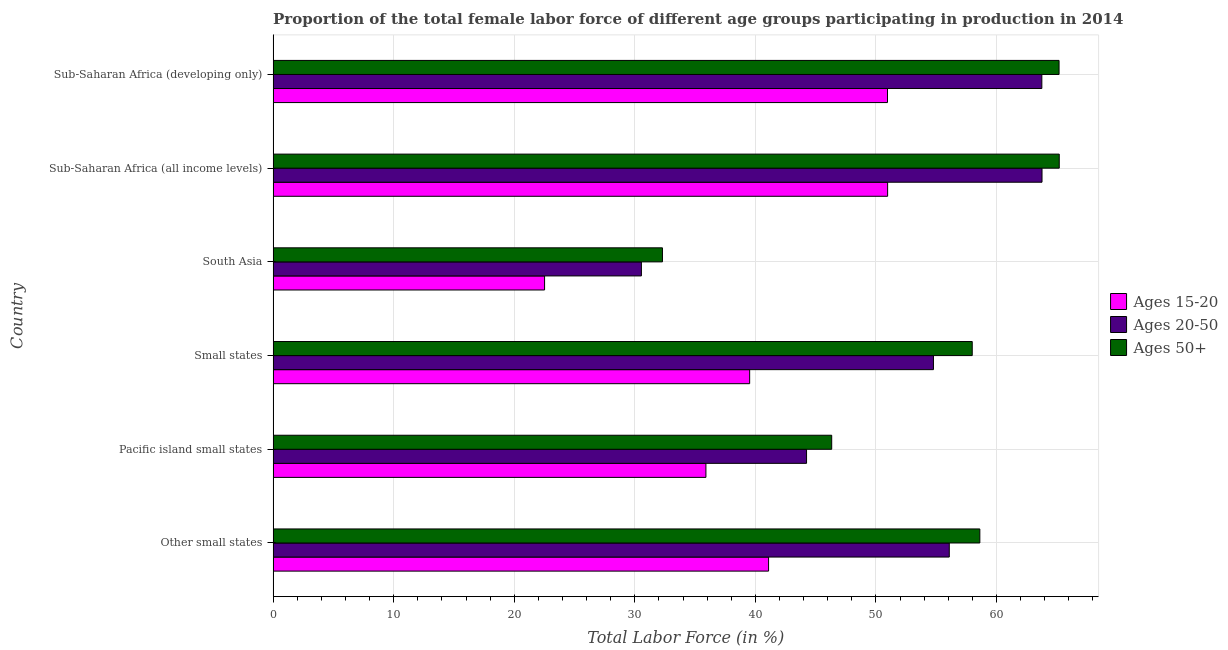How many different coloured bars are there?
Offer a very short reply. 3. How many groups of bars are there?
Your answer should be very brief. 6. Are the number of bars on each tick of the Y-axis equal?
Offer a terse response. Yes. How many bars are there on the 5th tick from the top?
Your answer should be compact. 3. What is the label of the 5th group of bars from the top?
Your answer should be compact. Pacific island small states. What is the percentage of female labor force within the age group 20-50 in Small states?
Make the answer very short. 54.77. Across all countries, what is the maximum percentage of female labor force within the age group 20-50?
Your answer should be very brief. 63.78. Across all countries, what is the minimum percentage of female labor force above age 50?
Ensure brevity in your answer.  32.29. In which country was the percentage of female labor force within the age group 20-50 maximum?
Your answer should be compact. Sub-Saharan Africa (all income levels). What is the total percentage of female labor force within the age group 20-50 in the graph?
Provide a succinct answer. 313.18. What is the difference between the percentage of female labor force above age 50 in South Asia and that in Sub-Saharan Africa (all income levels)?
Your response must be concise. -32.91. What is the difference between the percentage of female labor force within the age group 15-20 in South Asia and the percentage of female labor force within the age group 20-50 in Other small states?
Provide a short and direct response. -33.57. What is the average percentage of female labor force above age 50 per country?
Offer a very short reply. 54.27. What is the difference between the percentage of female labor force above age 50 and percentage of female labor force within the age group 20-50 in South Asia?
Keep it short and to the point. 1.75. What is the ratio of the percentage of female labor force within the age group 15-20 in Other small states to that in South Asia?
Your response must be concise. 1.82. Is the percentage of female labor force within the age group 20-50 in Other small states less than that in South Asia?
Keep it short and to the point. No. What is the difference between the highest and the second highest percentage of female labor force within the age group 15-20?
Offer a terse response. 0.01. What is the difference between the highest and the lowest percentage of female labor force above age 50?
Give a very brief answer. 32.91. In how many countries, is the percentage of female labor force within the age group 20-50 greater than the average percentage of female labor force within the age group 20-50 taken over all countries?
Your answer should be compact. 4. What does the 3rd bar from the top in Pacific island small states represents?
Offer a very short reply. Ages 15-20. What does the 3rd bar from the bottom in Pacific island small states represents?
Your answer should be compact. Ages 50+. Is it the case that in every country, the sum of the percentage of female labor force within the age group 15-20 and percentage of female labor force within the age group 20-50 is greater than the percentage of female labor force above age 50?
Your answer should be compact. Yes. Are all the bars in the graph horizontal?
Offer a terse response. Yes. How many countries are there in the graph?
Provide a short and direct response. 6. What is the difference between two consecutive major ticks on the X-axis?
Offer a very short reply. 10. How are the legend labels stacked?
Your response must be concise. Vertical. What is the title of the graph?
Give a very brief answer. Proportion of the total female labor force of different age groups participating in production in 2014. Does "Food" appear as one of the legend labels in the graph?
Provide a short and direct response. No. What is the label or title of the Y-axis?
Give a very brief answer. Country. What is the Total Labor Force (in %) of Ages 15-20 in Other small states?
Offer a very short reply. 41.1. What is the Total Labor Force (in %) in Ages 20-50 in Other small states?
Your response must be concise. 56.08. What is the Total Labor Force (in %) in Ages 50+ in Other small states?
Give a very brief answer. 58.62. What is the Total Labor Force (in %) of Ages 15-20 in Pacific island small states?
Your answer should be very brief. 35.9. What is the Total Labor Force (in %) of Ages 20-50 in Pacific island small states?
Your answer should be very brief. 44.25. What is the Total Labor Force (in %) of Ages 50+ in Pacific island small states?
Provide a short and direct response. 46.33. What is the Total Labor Force (in %) of Ages 15-20 in Small states?
Offer a terse response. 39.53. What is the Total Labor Force (in %) of Ages 20-50 in Small states?
Give a very brief answer. 54.77. What is the Total Labor Force (in %) of Ages 50+ in Small states?
Provide a succinct answer. 57.99. What is the Total Labor Force (in %) of Ages 15-20 in South Asia?
Give a very brief answer. 22.52. What is the Total Labor Force (in %) in Ages 20-50 in South Asia?
Keep it short and to the point. 30.55. What is the Total Labor Force (in %) of Ages 50+ in South Asia?
Offer a terse response. 32.29. What is the Total Labor Force (in %) in Ages 15-20 in Sub-Saharan Africa (all income levels)?
Offer a very short reply. 50.97. What is the Total Labor Force (in %) in Ages 20-50 in Sub-Saharan Africa (all income levels)?
Offer a terse response. 63.78. What is the Total Labor Force (in %) in Ages 50+ in Sub-Saharan Africa (all income levels)?
Offer a terse response. 65.2. What is the Total Labor Force (in %) of Ages 15-20 in Sub-Saharan Africa (developing only)?
Keep it short and to the point. 50.96. What is the Total Labor Force (in %) in Ages 20-50 in Sub-Saharan Africa (developing only)?
Make the answer very short. 63.76. What is the Total Labor Force (in %) of Ages 50+ in Sub-Saharan Africa (developing only)?
Your answer should be compact. 65.19. Across all countries, what is the maximum Total Labor Force (in %) in Ages 15-20?
Provide a succinct answer. 50.97. Across all countries, what is the maximum Total Labor Force (in %) in Ages 20-50?
Give a very brief answer. 63.78. Across all countries, what is the maximum Total Labor Force (in %) in Ages 50+?
Give a very brief answer. 65.2. Across all countries, what is the minimum Total Labor Force (in %) in Ages 15-20?
Give a very brief answer. 22.52. Across all countries, what is the minimum Total Labor Force (in %) of Ages 20-50?
Your response must be concise. 30.55. Across all countries, what is the minimum Total Labor Force (in %) of Ages 50+?
Offer a terse response. 32.29. What is the total Total Labor Force (in %) of Ages 15-20 in the graph?
Make the answer very short. 240.96. What is the total Total Labor Force (in %) in Ages 20-50 in the graph?
Your answer should be very brief. 313.18. What is the total Total Labor Force (in %) of Ages 50+ in the graph?
Give a very brief answer. 325.62. What is the difference between the Total Labor Force (in %) of Ages 15-20 in Other small states and that in Pacific island small states?
Give a very brief answer. 5.2. What is the difference between the Total Labor Force (in %) in Ages 20-50 in Other small states and that in Pacific island small states?
Offer a terse response. 11.84. What is the difference between the Total Labor Force (in %) of Ages 50+ in Other small states and that in Pacific island small states?
Offer a terse response. 12.29. What is the difference between the Total Labor Force (in %) in Ages 15-20 in Other small states and that in Small states?
Keep it short and to the point. 1.57. What is the difference between the Total Labor Force (in %) in Ages 20-50 in Other small states and that in Small states?
Your answer should be very brief. 1.31. What is the difference between the Total Labor Force (in %) in Ages 50+ in Other small states and that in Small states?
Offer a terse response. 0.63. What is the difference between the Total Labor Force (in %) of Ages 15-20 in Other small states and that in South Asia?
Ensure brevity in your answer.  18.58. What is the difference between the Total Labor Force (in %) of Ages 20-50 in Other small states and that in South Asia?
Make the answer very short. 25.54. What is the difference between the Total Labor Force (in %) in Ages 50+ in Other small states and that in South Asia?
Your response must be concise. 26.32. What is the difference between the Total Labor Force (in %) in Ages 15-20 in Other small states and that in Sub-Saharan Africa (all income levels)?
Make the answer very short. -9.87. What is the difference between the Total Labor Force (in %) in Ages 20-50 in Other small states and that in Sub-Saharan Africa (all income levels)?
Make the answer very short. -7.69. What is the difference between the Total Labor Force (in %) in Ages 50+ in Other small states and that in Sub-Saharan Africa (all income levels)?
Provide a short and direct response. -6.59. What is the difference between the Total Labor Force (in %) of Ages 15-20 in Other small states and that in Sub-Saharan Africa (developing only)?
Ensure brevity in your answer.  -9.86. What is the difference between the Total Labor Force (in %) in Ages 20-50 in Other small states and that in Sub-Saharan Africa (developing only)?
Provide a short and direct response. -7.68. What is the difference between the Total Labor Force (in %) of Ages 50+ in Other small states and that in Sub-Saharan Africa (developing only)?
Keep it short and to the point. -6.57. What is the difference between the Total Labor Force (in %) of Ages 15-20 in Pacific island small states and that in Small states?
Offer a terse response. -3.63. What is the difference between the Total Labor Force (in %) of Ages 20-50 in Pacific island small states and that in Small states?
Offer a very short reply. -10.53. What is the difference between the Total Labor Force (in %) of Ages 50+ in Pacific island small states and that in Small states?
Provide a succinct answer. -11.66. What is the difference between the Total Labor Force (in %) in Ages 15-20 in Pacific island small states and that in South Asia?
Offer a terse response. 13.38. What is the difference between the Total Labor Force (in %) in Ages 20-50 in Pacific island small states and that in South Asia?
Offer a very short reply. 13.7. What is the difference between the Total Labor Force (in %) in Ages 50+ in Pacific island small states and that in South Asia?
Ensure brevity in your answer.  14.04. What is the difference between the Total Labor Force (in %) of Ages 15-20 in Pacific island small states and that in Sub-Saharan Africa (all income levels)?
Ensure brevity in your answer.  -15.07. What is the difference between the Total Labor Force (in %) of Ages 20-50 in Pacific island small states and that in Sub-Saharan Africa (all income levels)?
Provide a short and direct response. -19.53. What is the difference between the Total Labor Force (in %) of Ages 50+ in Pacific island small states and that in Sub-Saharan Africa (all income levels)?
Offer a very short reply. -18.87. What is the difference between the Total Labor Force (in %) in Ages 15-20 in Pacific island small states and that in Sub-Saharan Africa (developing only)?
Provide a succinct answer. -15.06. What is the difference between the Total Labor Force (in %) of Ages 20-50 in Pacific island small states and that in Sub-Saharan Africa (developing only)?
Keep it short and to the point. -19.52. What is the difference between the Total Labor Force (in %) of Ages 50+ in Pacific island small states and that in Sub-Saharan Africa (developing only)?
Provide a short and direct response. -18.86. What is the difference between the Total Labor Force (in %) of Ages 15-20 in Small states and that in South Asia?
Make the answer very short. 17.01. What is the difference between the Total Labor Force (in %) of Ages 20-50 in Small states and that in South Asia?
Offer a very short reply. 24.22. What is the difference between the Total Labor Force (in %) in Ages 50+ in Small states and that in South Asia?
Your answer should be compact. 25.69. What is the difference between the Total Labor Force (in %) of Ages 15-20 in Small states and that in Sub-Saharan Africa (all income levels)?
Offer a very short reply. -11.44. What is the difference between the Total Labor Force (in %) in Ages 20-50 in Small states and that in Sub-Saharan Africa (all income levels)?
Make the answer very short. -9. What is the difference between the Total Labor Force (in %) of Ages 50+ in Small states and that in Sub-Saharan Africa (all income levels)?
Your answer should be compact. -7.22. What is the difference between the Total Labor Force (in %) of Ages 15-20 in Small states and that in Sub-Saharan Africa (developing only)?
Give a very brief answer. -11.43. What is the difference between the Total Labor Force (in %) of Ages 20-50 in Small states and that in Sub-Saharan Africa (developing only)?
Offer a terse response. -8.99. What is the difference between the Total Labor Force (in %) of Ages 50+ in Small states and that in Sub-Saharan Africa (developing only)?
Offer a terse response. -7.2. What is the difference between the Total Labor Force (in %) of Ages 15-20 in South Asia and that in Sub-Saharan Africa (all income levels)?
Your answer should be very brief. -28.45. What is the difference between the Total Labor Force (in %) of Ages 20-50 in South Asia and that in Sub-Saharan Africa (all income levels)?
Offer a terse response. -33.23. What is the difference between the Total Labor Force (in %) of Ages 50+ in South Asia and that in Sub-Saharan Africa (all income levels)?
Your answer should be compact. -32.91. What is the difference between the Total Labor Force (in %) in Ages 15-20 in South Asia and that in Sub-Saharan Africa (developing only)?
Your answer should be compact. -28.44. What is the difference between the Total Labor Force (in %) in Ages 20-50 in South Asia and that in Sub-Saharan Africa (developing only)?
Provide a short and direct response. -33.21. What is the difference between the Total Labor Force (in %) of Ages 50+ in South Asia and that in Sub-Saharan Africa (developing only)?
Offer a very short reply. -32.9. What is the difference between the Total Labor Force (in %) in Ages 15-20 in Sub-Saharan Africa (all income levels) and that in Sub-Saharan Africa (developing only)?
Ensure brevity in your answer.  0.01. What is the difference between the Total Labor Force (in %) of Ages 20-50 in Sub-Saharan Africa (all income levels) and that in Sub-Saharan Africa (developing only)?
Your response must be concise. 0.01. What is the difference between the Total Labor Force (in %) of Ages 50+ in Sub-Saharan Africa (all income levels) and that in Sub-Saharan Africa (developing only)?
Offer a very short reply. 0.01. What is the difference between the Total Labor Force (in %) of Ages 15-20 in Other small states and the Total Labor Force (in %) of Ages 20-50 in Pacific island small states?
Give a very brief answer. -3.15. What is the difference between the Total Labor Force (in %) in Ages 15-20 in Other small states and the Total Labor Force (in %) in Ages 50+ in Pacific island small states?
Ensure brevity in your answer.  -5.24. What is the difference between the Total Labor Force (in %) in Ages 20-50 in Other small states and the Total Labor Force (in %) in Ages 50+ in Pacific island small states?
Your answer should be compact. 9.75. What is the difference between the Total Labor Force (in %) of Ages 15-20 in Other small states and the Total Labor Force (in %) of Ages 20-50 in Small states?
Your answer should be compact. -13.68. What is the difference between the Total Labor Force (in %) in Ages 15-20 in Other small states and the Total Labor Force (in %) in Ages 50+ in Small states?
Make the answer very short. -16.89. What is the difference between the Total Labor Force (in %) of Ages 20-50 in Other small states and the Total Labor Force (in %) of Ages 50+ in Small states?
Ensure brevity in your answer.  -1.9. What is the difference between the Total Labor Force (in %) of Ages 15-20 in Other small states and the Total Labor Force (in %) of Ages 20-50 in South Asia?
Provide a succinct answer. 10.55. What is the difference between the Total Labor Force (in %) in Ages 15-20 in Other small states and the Total Labor Force (in %) in Ages 50+ in South Asia?
Keep it short and to the point. 8.8. What is the difference between the Total Labor Force (in %) in Ages 20-50 in Other small states and the Total Labor Force (in %) in Ages 50+ in South Asia?
Ensure brevity in your answer.  23.79. What is the difference between the Total Labor Force (in %) in Ages 15-20 in Other small states and the Total Labor Force (in %) in Ages 20-50 in Sub-Saharan Africa (all income levels)?
Give a very brief answer. -22.68. What is the difference between the Total Labor Force (in %) of Ages 15-20 in Other small states and the Total Labor Force (in %) of Ages 50+ in Sub-Saharan Africa (all income levels)?
Offer a very short reply. -24.11. What is the difference between the Total Labor Force (in %) in Ages 20-50 in Other small states and the Total Labor Force (in %) in Ages 50+ in Sub-Saharan Africa (all income levels)?
Your response must be concise. -9.12. What is the difference between the Total Labor Force (in %) of Ages 15-20 in Other small states and the Total Labor Force (in %) of Ages 20-50 in Sub-Saharan Africa (developing only)?
Your answer should be very brief. -22.67. What is the difference between the Total Labor Force (in %) in Ages 15-20 in Other small states and the Total Labor Force (in %) in Ages 50+ in Sub-Saharan Africa (developing only)?
Provide a short and direct response. -24.09. What is the difference between the Total Labor Force (in %) in Ages 20-50 in Other small states and the Total Labor Force (in %) in Ages 50+ in Sub-Saharan Africa (developing only)?
Your answer should be compact. -9.11. What is the difference between the Total Labor Force (in %) in Ages 15-20 in Pacific island small states and the Total Labor Force (in %) in Ages 20-50 in Small states?
Give a very brief answer. -18.87. What is the difference between the Total Labor Force (in %) of Ages 15-20 in Pacific island small states and the Total Labor Force (in %) of Ages 50+ in Small states?
Your answer should be very brief. -22.09. What is the difference between the Total Labor Force (in %) in Ages 20-50 in Pacific island small states and the Total Labor Force (in %) in Ages 50+ in Small states?
Keep it short and to the point. -13.74. What is the difference between the Total Labor Force (in %) in Ages 15-20 in Pacific island small states and the Total Labor Force (in %) in Ages 20-50 in South Asia?
Provide a short and direct response. 5.35. What is the difference between the Total Labor Force (in %) in Ages 15-20 in Pacific island small states and the Total Labor Force (in %) in Ages 50+ in South Asia?
Ensure brevity in your answer.  3.61. What is the difference between the Total Labor Force (in %) of Ages 20-50 in Pacific island small states and the Total Labor Force (in %) of Ages 50+ in South Asia?
Your answer should be compact. 11.95. What is the difference between the Total Labor Force (in %) of Ages 15-20 in Pacific island small states and the Total Labor Force (in %) of Ages 20-50 in Sub-Saharan Africa (all income levels)?
Make the answer very short. -27.88. What is the difference between the Total Labor Force (in %) of Ages 15-20 in Pacific island small states and the Total Labor Force (in %) of Ages 50+ in Sub-Saharan Africa (all income levels)?
Keep it short and to the point. -29.31. What is the difference between the Total Labor Force (in %) in Ages 20-50 in Pacific island small states and the Total Labor Force (in %) in Ages 50+ in Sub-Saharan Africa (all income levels)?
Offer a terse response. -20.96. What is the difference between the Total Labor Force (in %) in Ages 15-20 in Pacific island small states and the Total Labor Force (in %) in Ages 20-50 in Sub-Saharan Africa (developing only)?
Provide a short and direct response. -27.86. What is the difference between the Total Labor Force (in %) of Ages 15-20 in Pacific island small states and the Total Labor Force (in %) of Ages 50+ in Sub-Saharan Africa (developing only)?
Provide a succinct answer. -29.29. What is the difference between the Total Labor Force (in %) in Ages 20-50 in Pacific island small states and the Total Labor Force (in %) in Ages 50+ in Sub-Saharan Africa (developing only)?
Your answer should be very brief. -20.94. What is the difference between the Total Labor Force (in %) of Ages 15-20 in Small states and the Total Labor Force (in %) of Ages 20-50 in South Asia?
Your answer should be very brief. 8.98. What is the difference between the Total Labor Force (in %) in Ages 15-20 in Small states and the Total Labor Force (in %) in Ages 50+ in South Asia?
Make the answer very short. 7.23. What is the difference between the Total Labor Force (in %) of Ages 20-50 in Small states and the Total Labor Force (in %) of Ages 50+ in South Asia?
Give a very brief answer. 22.48. What is the difference between the Total Labor Force (in %) of Ages 15-20 in Small states and the Total Labor Force (in %) of Ages 20-50 in Sub-Saharan Africa (all income levels)?
Keep it short and to the point. -24.25. What is the difference between the Total Labor Force (in %) of Ages 15-20 in Small states and the Total Labor Force (in %) of Ages 50+ in Sub-Saharan Africa (all income levels)?
Ensure brevity in your answer.  -25.68. What is the difference between the Total Labor Force (in %) in Ages 20-50 in Small states and the Total Labor Force (in %) in Ages 50+ in Sub-Saharan Africa (all income levels)?
Ensure brevity in your answer.  -10.43. What is the difference between the Total Labor Force (in %) of Ages 15-20 in Small states and the Total Labor Force (in %) of Ages 20-50 in Sub-Saharan Africa (developing only)?
Your answer should be compact. -24.23. What is the difference between the Total Labor Force (in %) in Ages 15-20 in Small states and the Total Labor Force (in %) in Ages 50+ in Sub-Saharan Africa (developing only)?
Your answer should be compact. -25.66. What is the difference between the Total Labor Force (in %) of Ages 20-50 in Small states and the Total Labor Force (in %) of Ages 50+ in Sub-Saharan Africa (developing only)?
Your answer should be very brief. -10.42. What is the difference between the Total Labor Force (in %) in Ages 15-20 in South Asia and the Total Labor Force (in %) in Ages 20-50 in Sub-Saharan Africa (all income levels)?
Your answer should be very brief. -41.26. What is the difference between the Total Labor Force (in %) in Ages 15-20 in South Asia and the Total Labor Force (in %) in Ages 50+ in Sub-Saharan Africa (all income levels)?
Your answer should be very brief. -42.69. What is the difference between the Total Labor Force (in %) in Ages 20-50 in South Asia and the Total Labor Force (in %) in Ages 50+ in Sub-Saharan Africa (all income levels)?
Provide a succinct answer. -34.66. What is the difference between the Total Labor Force (in %) of Ages 15-20 in South Asia and the Total Labor Force (in %) of Ages 20-50 in Sub-Saharan Africa (developing only)?
Your answer should be very brief. -41.24. What is the difference between the Total Labor Force (in %) of Ages 15-20 in South Asia and the Total Labor Force (in %) of Ages 50+ in Sub-Saharan Africa (developing only)?
Your response must be concise. -42.67. What is the difference between the Total Labor Force (in %) in Ages 20-50 in South Asia and the Total Labor Force (in %) in Ages 50+ in Sub-Saharan Africa (developing only)?
Keep it short and to the point. -34.64. What is the difference between the Total Labor Force (in %) of Ages 15-20 in Sub-Saharan Africa (all income levels) and the Total Labor Force (in %) of Ages 20-50 in Sub-Saharan Africa (developing only)?
Offer a very short reply. -12.79. What is the difference between the Total Labor Force (in %) of Ages 15-20 in Sub-Saharan Africa (all income levels) and the Total Labor Force (in %) of Ages 50+ in Sub-Saharan Africa (developing only)?
Keep it short and to the point. -14.22. What is the difference between the Total Labor Force (in %) in Ages 20-50 in Sub-Saharan Africa (all income levels) and the Total Labor Force (in %) in Ages 50+ in Sub-Saharan Africa (developing only)?
Provide a short and direct response. -1.41. What is the average Total Labor Force (in %) in Ages 15-20 per country?
Provide a short and direct response. 40.16. What is the average Total Labor Force (in %) in Ages 20-50 per country?
Offer a very short reply. 52.2. What is the average Total Labor Force (in %) in Ages 50+ per country?
Keep it short and to the point. 54.27. What is the difference between the Total Labor Force (in %) of Ages 15-20 and Total Labor Force (in %) of Ages 20-50 in Other small states?
Keep it short and to the point. -14.99. What is the difference between the Total Labor Force (in %) of Ages 15-20 and Total Labor Force (in %) of Ages 50+ in Other small states?
Your response must be concise. -17.52. What is the difference between the Total Labor Force (in %) of Ages 20-50 and Total Labor Force (in %) of Ages 50+ in Other small states?
Make the answer very short. -2.54. What is the difference between the Total Labor Force (in %) in Ages 15-20 and Total Labor Force (in %) in Ages 20-50 in Pacific island small states?
Offer a very short reply. -8.35. What is the difference between the Total Labor Force (in %) of Ages 15-20 and Total Labor Force (in %) of Ages 50+ in Pacific island small states?
Your response must be concise. -10.43. What is the difference between the Total Labor Force (in %) in Ages 20-50 and Total Labor Force (in %) in Ages 50+ in Pacific island small states?
Offer a terse response. -2.09. What is the difference between the Total Labor Force (in %) in Ages 15-20 and Total Labor Force (in %) in Ages 20-50 in Small states?
Give a very brief answer. -15.24. What is the difference between the Total Labor Force (in %) of Ages 15-20 and Total Labor Force (in %) of Ages 50+ in Small states?
Your answer should be compact. -18.46. What is the difference between the Total Labor Force (in %) in Ages 20-50 and Total Labor Force (in %) in Ages 50+ in Small states?
Provide a succinct answer. -3.22. What is the difference between the Total Labor Force (in %) of Ages 15-20 and Total Labor Force (in %) of Ages 20-50 in South Asia?
Give a very brief answer. -8.03. What is the difference between the Total Labor Force (in %) in Ages 15-20 and Total Labor Force (in %) in Ages 50+ in South Asia?
Keep it short and to the point. -9.78. What is the difference between the Total Labor Force (in %) of Ages 20-50 and Total Labor Force (in %) of Ages 50+ in South Asia?
Your answer should be very brief. -1.75. What is the difference between the Total Labor Force (in %) of Ages 15-20 and Total Labor Force (in %) of Ages 20-50 in Sub-Saharan Africa (all income levels)?
Make the answer very short. -12.81. What is the difference between the Total Labor Force (in %) of Ages 15-20 and Total Labor Force (in %) of Ages 50+ in Sub-Saharan Africa (all income levels)?
Your response must be concise. -14.24. What is the difference between the Total Labor Force (in %) of Ages 20-50 and Total Labor Force (in %) of Ages 50+ in Sub-Saharan Africa (all income levels)?
Your answer should be very brief. -1.43. What is the difference between the Total Labor Force (in %) in Ages 15-20 and Total Labor Force (in %) in Ages 20-50 in Sub-Saharan Africa (developing only)?
Ensure brevity in your answer.  -12.8. What is the difference between the Total Labor Force (in %) of Ages 15-20 and Total Labor Force (in %) of Ages 50+ in Sub-Saharan Africa (developing only)?
Ensure brevity in your answer.  -14.23. What is the difference between the Total Labor Force (in %) of Ages 20-50 and Total Labor Force (in %) of Ages 50+ in Sub-Saharan Africa (developing only)?
Make the answer very short. -1.43. What is the ratio of the Total Labor Force (in %) in Ages 15-20 in Other small states to that in Pacific island small states?
Give a very brief answer. 1.14. What is the ratio of the Total Labor Force (in %) of Ages 20-50 in Other small states to that in Pacific island small states?
Provide a succinct answer. 1.27. What is the ratio of the Total Labor Force (in %) in Ages 50+ in Other small states to that in Pacific island small states?
Give a very brief answer. 1.27. What is the ratio of the Total Labor Force (in %) of Ages 15-20 in Other small states to that in Small states?
Your response must be concise. 1.04. What is the ratio of the Total Labor Force (in %) of Ages 20-50 in Other small states to that in Small states?
Your answer should be very brief. 1.02. What is the ratio of the Total Labor Force (in %) of Ages 50+ in Other small states to that in Small states?
Provide a short and direct response. 1.01. What is the ratio of the Total Labor Force (in %) in Ages 15-20 in Other small states to that in South Asia?
Your answer should be compact. 1.83. What is the ratio of the Total Labor Force (in %) in Ages 20-50 in Other small states to that in South Asia?
Your answer should be compact. 1.84. What is the ratio of the Total Labor Force (in %) of Ages 50+ in Other small states to that in South Asia?
Offer a terse response. 1.82. What is the ratio of the Total Labor Force (in %) of Ages 15-20 in Other small states to that in Sub-Saharan Africa (all income levels)?
Offer a very short reply. 0.81. What is the ratio of the Total Labor Force (in %) of Ages 20-50 in Other small states to that in Sub-Saharan Africa (all income levels)?
Give a very brief answer. 0.88. What is the ratio of the Total Labor Force (in %) of Ages 50+ in Other small states to that in Sub-Saharan Africa (all income levels)?
Provide a short and direct response. 0.9. What is the ratio of the Total Labor Force (in %) of Ages 15-20 in Other small states to that in Sub-Saharan Africa (developing only)?
Offer a very short reply. 0.81. What is the ratio of the Total Labor Force (in %) in Ages 20-50 in Other small states to that in Sub-Saharan Africa (developing only)?
Provide a short and direct response. 0.88. What is the ratio of the Total Labor Force (in %) of Ages 50+ in Other small states to that in Sub-Saharan Africa (developing only)?
Make the answer very short. 0.9. What is the ratio of the Total Labor Force (in %) of Ages 15-20 in Pacific island small states to that in Small states?
Provide a short and direct response. 0.91. What is the ratio of the Total Labor Force (in %) in Ages 20-50 in Pacific island small states to that in Small states?
Make the answer very short. 0.81. What is the ratio of the Total Labor Force (in %) in Ages 50+ in Pacific island small states to that in Small states?
Your answer should be very brief. 0.8. What is the ratio of the Total Labor Force (in %) of Ages 15-20 in Pacific island small states to that in South Asia?
Ensure brevity in your answer.  1.59. What is the ratio of the Total Labor Force (in %) of Ages 20-50 in Pacific island small states to that in South Asia?
Provide a short and direct response. 1.45. What is the ratio of the Total Labor Force (in %) of Ages 50+ in Pacific island small states to that in South Asia?
Ensure brevity in your answer.  1.43. What is the ratio of the Total Labor Force (in %) in Ages 15-20 in Pacific island small states to that in Sub-Saharan Africa (all income levels)?
Keep it short and to the point. 0.7. What is the ratio of the Total Labor Force (in %) of Ages 20-50 in Pacific island small states to that in Sub-Saharan Africa (all income levels)?
Ensure brevity in your answer.  0.69. What is the ratio of the Total Labor Force (in %) of Ages 50+ in Pacific island small states to that in Sub-Saharan Africa (all income levels)?
Provide a short and direct response. 0.71. What is the ratio of the Total Labor Force (in %) in Ages 15-20 in Pacific island small states to that in Sub-Saharan Africa (developing only)?
Offer a very short reply. 0.7. What is the ratio of the Total Labor Force (in %) in Ages 20-50 in Pacific island small states to that in Sub-Saharan Africa (developing only)?
Give a very brief answer. 0.69. What is the ratio of the Total Labor Force (in %) in Ages 50+ in Pacific island small states to that in Sub-Saharan Africa (developing only)?
Offer a very short reply. 0.71. What is the ratio of the Total Labor Force (in %) in Ages 15-20 in Small states to that in South Asia?
Provide a succinct answer. 1.76. What is the ratio of the Total Labor Force (in %) in Ages 20-50 in Small states to that in South Asia?
Provide a short and direct response. 1.79. What is the ratio of the Total Labor Force (in %) in Ages 50+ in Small states to that in South Asia?
Your response must be concise. 1.8. What is the ratio of the Total Labor Force (in %) in Ages 15-20 in Small states to that in Sub-Saharan Africa (all income levels)?
Offer a terse response. 0.78. What is the ratio of the Total Labor Force (in %) of Ages 20-50 in Small states to that in Sub-Saharan Africa (all income levels)?
Ensure brevity in your answer.  0.86. What is the ratio of the Total Labor Force (in %) of Ages 50+ in Small states to that in Sub-Saharan Africa (all income levels)?
Make the answer very short. 0.89. What is the ratio of the Total Labor Force (in %) in Ages 15-20 in Small states to that in Sub-Saharan Africa (developing only)?
Provide a short and direct response. 0.78. What is the ratio of the Total Labor Force (in %) of Ages 20-50 in Small states to that in Sub-Saharan Africa (developing only)?
Keep it short and to the point. 0.86. What is the ratio of the Total Labor Force (in %) of Ages 50+ in Small states to that in Sub-Saharan Africa (developing only)?
Make the answer very short. 0.89. What is the ratio of the Total Labor Force (in %) of Ages 15-20 in South Asia to that in Sub-Saharan Africa (all income levels)?
Offer a very short reply. 0.44. What is the ratio of the Total Labor Force (in %) of Ages 20-50 in South Asia to that in Sub-Saharan Africa (all income levels)?
Your answer should be compact. 0.48. What is the ratio of the Total Labor Force (in %) in Ages 50+ in South Asia to that in Sub-Saharan Africa (all income levels)?
Ensure brevity in your answer.  0.5. What is the ratio of the Total Labor Force (in %) in Ages 15-20 in South Asia to that in Sub-Saharan Africa (developing only)?
Give a very brief answer. 0.44. What is the ratio of the Total Labor Force (in %) in Ages 20-50 in South Asia to that in Sub-Saharan Africa (developing only)?
Your answer should be very brief. 0.48. What is the ratio of the Total Labor Force (in %) in Ages 50+ in South Asia to that in Sub-Saharan Africa (developing only)?
Make the answer very short. 0.5. What is the ratio of the Total Labor Force (in %) of Ages 50+ in Sub-Saharan Africa (all income levels) to that in Sub-Saharan Africa (developing only)?
Provide a short and direct response. 1. What is the difference between the highest and the second highest Total Labor Force (in %) of Ages 15-20?
Offer a terse response. 0.01. What is the difference between the highest and the second highest Total Labor Force (in %) in Ages 20-50?
Offer a very short reply. 0.01. What is the difference between the highest and the second highest Total Labor Force (in %) in Ages 50+?
Provide a succinct answer. 0.01. What is the difference between the highest and the lowest Total Labor Force (in %) of Ages 15-20?
Ensure brevity in your answer.  28.45. What is the difference between the highest and the lowest Total Labor Force (in %) of Ages 20-50?
Offer a very short reply. 33.23. What is the difference between the highest and the lowest Total Labor Force (in %) of Ages 50+?
Ensure brevity in your answer.  32.91. 